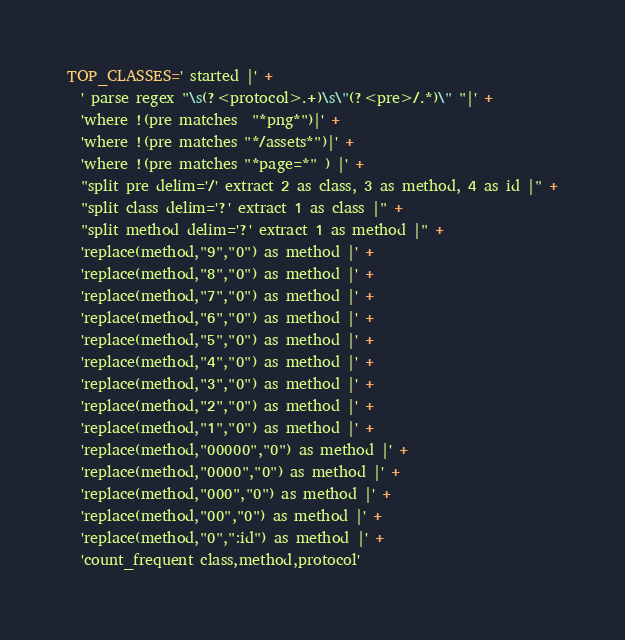<code> <loc_0><loc_0><loc_500><loc_500><_Ruby_>TOP_CLASSES=' started |' +
  ' parse regex "\s(?<protocol>.+)\s\"(?<pre>/.*)\" "|' +
  'where !(pre matches  "*png*")|' +
  'where !(pre matches "*/assets*")|' +
  'where !(pre matches "*page=*" ) |' +
  "split pre delim='/' extract 2 as class, 3 as method, 4 as id |" +
  "split class delim='?' extract 1 as class |" +
  "split method delim='?' extract 1 as method |" +
  'replace(method,"9","0") as method |' +
  'replace(method,"8","0") as method |' +
  'replace(method,"7","0") as method |' +
  'replace(method,"6","0") as method |' +
  'replace(method,"5","0") as method |' +
  'replace(method,"4","0") as method |' +
  'replace(method,"3","0") as method |' +
  'replace(method,"2","0") as method |' +
  'replace(method,"1","0") as method |' +
  'replace(method,"00000","0") as method |' + 
  'replace(method,"0000","0") as method |' + 
  'replace(method,"000","0") as method |' + 
  'replace(method,"00","0") as method |' + 
  'replace(method,"0",":id") as method |' + 
  'count_frequent class,method,protocol'
</code> 